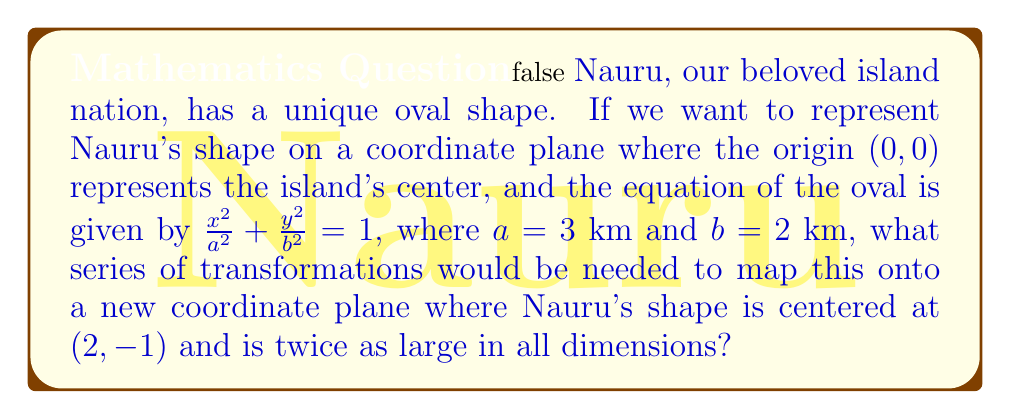Help me with this question. To solve this problem, we need to consider the following steps:

1) The original equation of Nauru's shape is:

   $$\frac{x^2}{3^2} + \frac{y^2}{2^2} = 1$$

2) To make the shape twice as large in all dimensions, we need to multiply both $a$ and $b$ by 2:

   $$\frac{x^2}{(2\cdot3)^2} + \frac{y^2}{(2\cdot2)^2} = 1$$

   Which simplifies to:

   $$\frac{x^2}{36} + \frac{y^2}{16} = 1$$

3) Now, we need to shift the center from (0,0) to (2,-1). This is done by replacing $x$ with $(x-2)$ and $y$ with $(y+1)$:

   $$\frac{(x-2)^2}{36} + \frac{(y+1)^2}{16} = 1$$

4) Therefore, the series of transformations needed are:
   - Dilation: Scale the original shape by a factor of 2 in all directions.
   - Translation: Move the center 2 units right and 1 unit down.

These transformations can be represented mathematically as:

   $$(x,y) \rightarrow (2x, 2y) \rightarrow (2x+2, 2y-1)$$
Answer: The required transformations are:
1) Dilation by a factor of 2
2) Translation by (2, -1)

Mathematically: $(x,y) \rightarrow (2x+2, 2y-1)$ 